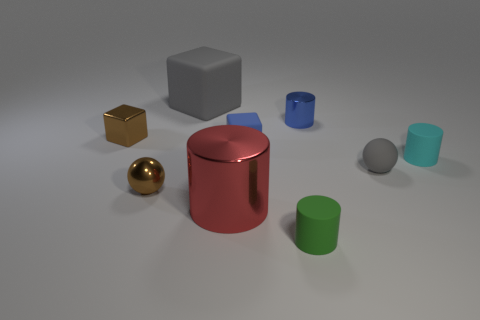Subtract all yellow cylinders. Subtract all green blocks. How many cylinders are left? 4 Add 1 gray blocks. How many objects exist? 10 Subtract all cylinders. How many objects are left? 5 Add 3 tiny shiny blocks. How many tiny shiny blocks exist? 4 Subtract 1 blue cylinders. How many objects are left? 8 Subtract all big cylinders. Subtract all tiny metal spheres. How many objects are left? 7 Add 4 tiny blue metal cylinders. How many tiny blue metal cylinders are left? 5 